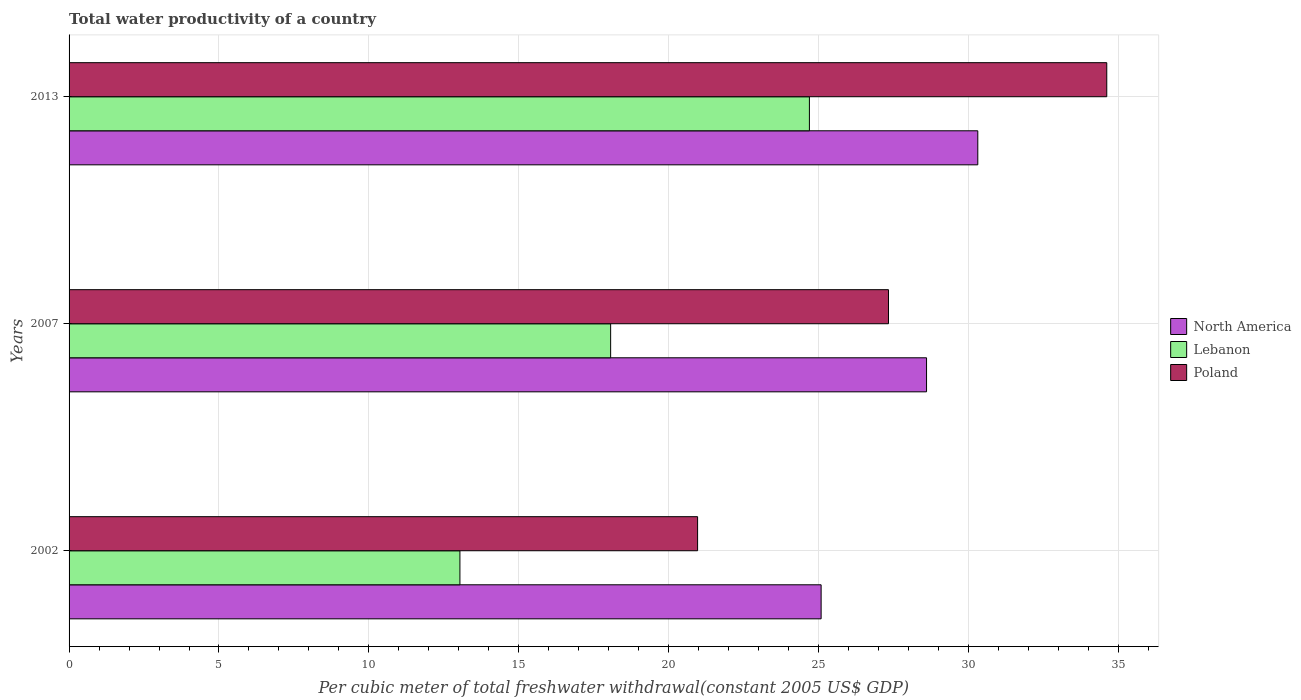How many groups of bars are there?
Your response must be concise. 3. How many bars are there on the 3rd tick from the top?
Your answer should be very brief. 3. How many bars are there on the 2nd tick from the bottom?
Your response must be concise. 3. What is the label of the 1st group of bars from the top?
Make the answer very short. 2013. What is the total water productivity in Poland in 2013?
Give a very brief answer. 34.61. Across all years, what is the maximum total water productivity in Lebanon?
Keep it short and to the point. 24.69. Across all years, what is the minimum total water productivity in North America?
Offer a very short reply. 25.08. What is the total total water productivity in North America in the graph?
Your response must be concise. 83.99. What is the difference between the total water productivity in Poland in 2002 and that in 2007?
Make the answer very short. -6.37. What is the difference between the total water productivity in North America in 2013 and the total water productivity in Lebanon in 2002?
Offer a terse response. 17.27. What is the average total water productivity in North America per year?
Keep it short and to the point. 28. In the year 2002, what is the difference between the total water productivity in North America and total water productivity in Lebanon?
Offer a terse response. 12.05. What is the ratio of the total water productivity in North America in 2007 to that in 2013?
Keep it short and to the point. 0.94. Is the difference between the total water productivity in North America in 2002 and 2007 greater than the difference between the total water productivity in Lebanon in 2002 and 2007?
Your response must be concise. Yes. What is the difference between the highest and the second highest total water productivity in Poland?
Your answer should be very brief. 7.28. What is the difference between the highest and the lowest total water productivity in Lebanon?
Provide a short and direct response. 11.66. Is the sum of the total water productivity in Poland in 2007 and 2013 greater than the maximum total water productivity in Lebanon across all years?
Your answer should be very brief. Yes. What does the 3rd bar from the top in 2007 represents?
Offer a very short reply. North America. How many years are there in the graph?
Your answer should be very brief. 3. What is the difference between two consecutive major ticks on the X-axis?
Ensure brevity in your answer.  5. Where does the legend appear in the graph?
Your answer should be very brief. Center right. How are the legend labels stacked?
Offer a very short reply. Vertical. What is the title of the graph?
Keep it short and to the point. Total water productivity of a country. What is the label or title of the X-axis?
Your answer should be very brief. Per cubic meter of total freshwater withdrawal(constant 2005 US$ GDP). What is the Per cubic meter of total freshwater withdrawal(constant 2005 US$ GDP) in North America in 2002?
Your answer should be very brief. 25.08. What is the Per cubic meter of total freshwater withdrawal(constant 2005 US$ GDP) of Lebanon in 2002?
Make the answer very short. 13.04. What is the Per cubic meter of total freshwater withdrawal(constant 2005 US$ GDP) in Poland in 2002?
Keep it short and to the point. 20.96. What is the Per cubic meter of total freshwater withdrawal(constant 2005 US$ GDP) of North America in 2007?
Give a very brief answer. 28.6. What is the Per cubic meter of total freshwater withdrawal(constant 2005 US$ GDP) in Lebanon in 2007?
Offer a very short reply. 18.06. What is the Per cubic meter of total freshwater withdrawal(constant 2005 US$ GDP) in Poland in 2007?
Your answer should be compact. 27.33. What is the Per cubic meter of total freshwater withdrawal(constant 2005 US$ GDP) of North America in 2013?
Provide a short and direct response. 30.31. What is the Per cubic meter of total freshwater withdrawal(constant 2005 US$ GDP) of Lebanon in 2013?
Your answer should be very brief. 24.69. What is the Per cubic meter of total freshwater withdrawal(constant 2005 US$ GDP) in Poland in 2013?
Your response must be concise. 34.61. Across all years, what is the maximum Per cubic meter of total freshwater withdrawal(constant 2005 US$ GDP) in North America?
Provide a succinct answer. 30.31. Across all years, what is the maximum Per cubic meter of total freshwater withdrawal(constant 2005 US$ GDP) in Lebanon?
Your answer should be very brief. 24.69. Across all years, what is the maximum Per cubic meter of total freshwater withdrawal(constant 2005 US$ GDP) in Poland?
Offer a terse response. 34.61. Across all years, what is the minimum Per cubic meter of total freshwater withdrawal(constant 2005 US$ GDP) of North America?
Your response must be concise. 25.08. Across all years, what is the minimum Per cubic meter of total freshwater withdrawal(constant 2005 US$ GDP) in Lebanon?
Your answer should be compact. 13.04. Across all years, what is the minimum Per cubic meter of total freshwater withdrawal(constant 2005 US$ GDP) of Poland?
Offer a terse response. 20.96. What is the total Per cubic meter of total freshwater withdrawal(constant 2005 US$ GDP) of North America in the graph?
Make the answer very short. 83.99. What is the total Per cubic meter of total freshwater withdrawal(constant 2005 US$ GDP) in Lebanon in the graph?
Offer a terse response. 55.79. What is the total Per cubic meter of total freshwater withdrawal(constant 2005 US$ GDP) of Poland in the graph?
Give a very brief answer. 82.9. What is the difference between the Per cubic meter of total freshwater withdrawal(constant 2005 US$ GDP) of North America in 2002 and that in 2007?
Ensure brevity in your answer.  -3.52. What is the difference between the Per cubic meter of total freshwater withdrawal(constant 2005 US$ GDP) in Lebanon in 2002 and that in 2007?
Your answer should be very brief. -5.03. What is the difference between the Per cubic meter of total freshwater withdrawal(constant 2005 US$ GDP) in Poland in 2002 and that in 2007?
Provide a short and direct response. -6.37. What is the difference between the Per cubic meter of total freshwater withdrawal(constant 2005 US$ GDP) in North America in 2002 and that in 2013?
Provide a succinct answer. -5.23. What is the difference between the Per cubic meter of total freshwater withdrawal(constant 2005 US$ GDP) in Lebanon in 2002 and that in 2013?
Provide a short and direct response. -11.66. What is the difference between the Per cubic meter of total freshwater withdrawal(constant 2005 US$ GDP) of Poland in 2002 and that in 2013?
Offer a very short reply. -13.65. What is the difference between the Per cubic meter of total freshwater withdrawal(constant 2005 US$ GDP) of North America in 2007 and that in 2013?
Provide a short and direct response. -1.71. What is the difference between the Per cubic meter of total freshwater withdrawal(constant 2005 US$ GDP) in Lebanon in 2007 and that in 2013?
Ensure brevity in your answer.  -6.63. What is the difference between the Per cubic meter of total freshwater withdrawal(constant 2005 US$ GDP) in Poland in 2007 and that in 2013?
Offer a terse response. -7.28. What is the difference between the Per cubic meter of total freshwater withdrawal(constant 2005 US$ GDP) in North America in 2002 and the Per cubic meter of total freshwater withdrawal(constant 2005 US$ GDP) in Lebanon in 2007?
Your response must be concise. 7.02. What is the difference between the Per cubic meter of total freshwater withdrawal(constant 2005 US$ GDP) in North America in 2002 and the Per cubic meter of total freshwater withdrawal(constant 2005 US$ GDP) in Poland in 2007?
Offer a very short reply. -2.25. What is the difference between the Per cubic meter of total freshwater withdrawal(constant 2005 US$ GDP) of Lebanon in 2002 and the Per cubic meter of total freshwater withdrawal(constant 2005 US$ GDP) of Poland in 2007?
Offer a terse response. -14.29. What is the difference between the Per cubic meter of total freshwater withdrawal(constant 2005 US$ GDP) in North America in 2002 and the Per cubic meter of total freshwater withdrawal(constant 2005 US$ GDP) in Lebanon in 2013?
Make the answer very short. 0.39. What is the difference between the Per cubic meter of total freshwater withdrawal(constant 2005 US$ GDP) in North America in 2002 and the Per cubic meter of total freshwater withdrawal(constant 2005 US$ GDP) in Poland in 2013?
Your answer should be very brief. -9.53. What is the difference between the Per cubic meter of total freshwater withdrawal(constant 2005 US$ GDP) in Lebanon in 2002 and the Per cubic meter of total freshwater withdrawal(constant 2005 US$ GDP) in Poland in 2013?
Your answer should be very brief. -21.57. What is the difference between the Per cubic meter of total freshwater withdrawal(constant 2005 US$ GDP) of North America in 2007 and the Per cubic meter of total freshwater withdrawal(constant 2005 US$ GDP) of Lebanon in 2013?
Offer a terse response. 3.91. What is the difference between the Per cubic meter of total freshwater withdrawal(constant 2005 US$ GDP) in North America in 2007 and the Per cubic meter of total freshwater withdrawal(constant 2005 US$ GDP) in Poland in 2013?
Give a very brief answer. -6.01. What is the difference between the Per cubic meter of total freshwater withdrawal(constant 2005 US$ GDP) in Lebanon in 2007 and the Per cubic meter of total freshwater withdrawal(constant 2005 US$ GDP) in Poland in 2013?
Offer a very short reply. -16.55. What is the average Per cubic meter of total freshwater withdrawal(constant 2005 US$ GDP) in North America per year?
Keep it short and to the point. 28. What is the average Per cubic meter of total freshwater withdrawal(constant 2005 US$ GDP) in Lebanon per year?
Offer a very short reply. 18.6. What is the average Per cubic meter of total freshwater withdrawal(constant 2005 US$ GDP) in Poland per year?
Give a very brief answer. 27.63. In the year 2002, what is the difference between the Per cubic meter of total freshwater withdrawal(constant 2005 US$ GDP) of North America and Per cubic meter of total freshwater withdrawal(constant 2005 US$ GDP) of Lebanon?
Provide a short and direct response. 12.05. In the year 2002, what is the difference between the Per cubic meter of total freshwater withdrawal(constant 2005 US$ GDP) in North America and Per cubic meter of total freshwater withdrawal(constant 2005 US$ GDP) in Poland?
Offer a very short reply. 4.12. In the year 2002, what is the difference between the Per cubic meter of total freshwater withdrawal(constant 2005 US$ GDP) in Lebanon and Per cubic meter of total freshwater withdrawal(constant 2005 US$ GDP) in Poland?
Keep it short and to the point. -7.93. In the year 2007, what is the difference between the Per cubic meter of total freshwater withdrawal(constant 2005 US$ GDP) in North America and Per cubic meter of total freshwater withdrawal(constant 2005 US$ GDP) in Lebanon?
Make the answer very short. 10.54. In the year 2007, what is the difference between the Per cubic meter of total freshwater withdrawal(constant 2005 US$ GDP) in North America and Per cubic meter of total freshwater withdrawal(constant 2005 US$ GDP) in Poland?
Your answer should be very brief. 1.27. In the year 2007, what is the difference between the Per cubic meter of total freshwater withdrawal(constant 2005 US$ GDP) of Lebanon and Per cubic meter of total freshwater withdrawal(constant 2005 US$ GDP) of Poland?
Give a very brief answer. -9.27. In the year 2013, what is the difference between the Per cubic meter of total freshwater withdrawal(constant 2005 US$ GDP) of North America and Per cubic meter of total freshwater withdrawal(constant 2005 US$ GDP) of Lebanon?
Offer a very short reply. 5.62. In the year 2013, what is the difference between the Per cubic meter of total freshwater withdrawal(constant 2005 US$ GDP) in North America and Per cubic meter of total freshwater withdrawal(constant 2005 US$ GDP) in Poland?
Offer a terse response. -4.3. In the year 2013, what is the difference between the Per cubic meter of total freshwater withdrawal(constant 2005 US$ GDP) in Lebanon and Per cubic meter of total freshwater withdrawal(constant 2005 US$ GDP) in Poland?
Offer a terse response. -9.92. What is the ratio of the Per cubic meter of total freshwater withdrawal(constant 2005 US$ GDP) in North America in 2002 to that in 2007?
Ensure brevity in your answer.  0.88. What is the ratio of the Per cubic meter of total freshwater withdrawal(constant 2005 US$ GDP) in Lebanon in 2002 to that in 2007?
Make the answer very short. 0.72. What is the ratio of the Per cubic meter of total freshwater withdrawal(constant 2005 US$ GDP) in Poland in 2002 to that in 2007?
Your response must be concise. 0.77. What is the ratio of the Per cubic meter of total freshwater withdrawal(constant 2005 US$ GDP) of North America in 2002 to that in 2013?
Your answer should be compact. 0.83. What is the ratio of the Per cubic meter of total freshwater withdrawal(constant 2005 US$ GDP) of Lebanon in 2002 to that in 2013?
Make the answer very short. 0.53. What is the ratio of the Per cubic meter of total freshwater withdrawal(constant 2005 US$ GDP) in Poland in 2002 to that in 2013?
Your answer should be compact. 0.61. What is the ratio of the Per cubic meter of total freshwater withdrawal(constant 2005 US$ GDP) in North America in 2007 to that in 2013?
Provide a succinct answer. 0.94. What is the ratio of the Per cubic meter of total freshwater withdrawal(constant 2005 US$ GDP) in Lebanon in 2007 to that in 2013?
Ensure brevity in your answer.  0.73. What is the ratio of the Per cubic meter of total freshwater withdrawal(constant 2005 US$ GDP) of Poland in 2007 to that in 2013?
Offer a very short reply. 0.79. What is the difference between the highest and the second highest Per cubic meter of total freshwater withdrawal(constant 2005 US$ GDP) of North America?
Provide a short and direct response. 1.71. What is the difference between the highest and the second highest Per cubic meter of total freshwater withdrawal(constant 2005 US$ GDP) in Lebanon?
Keep it short and to the point. 6.63. What is the difference between the highest and the second highest Per cubic meter of total freshwater withdrawal(constant 2005 US$ GDP) in Poland?
Your answer should be compact. 7.28. What is the difference between the highest and the lowest Per cubic meter of total freshwater withdrawal(constant 2005 US$ GDP) in North America?
Make the answer very short. 5.23. What is the difference between the highest and the lowest Per cubic meter of total freshwater withdrawal(constant 2005 US$ GDP) of Lebanon?
Offer a very short reply. 11.66. What is the difference between the highest and the lowest Per cubic meter of total freshwater withdrawal(constant 2005 US$ GDP) of Poland?
Offer a very short reply. 13.65. 